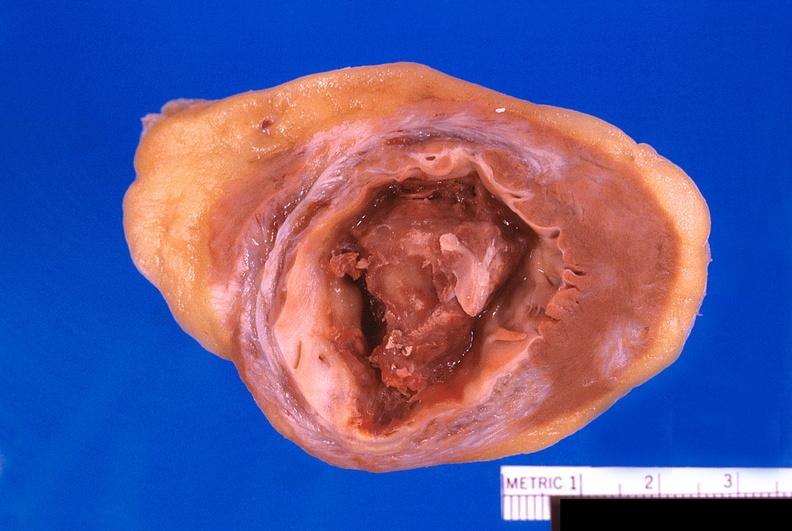does infant body show heart, old myocardial infarction with fibrosis and apical thrombus?
Answer the question using a single word or phrase. No 